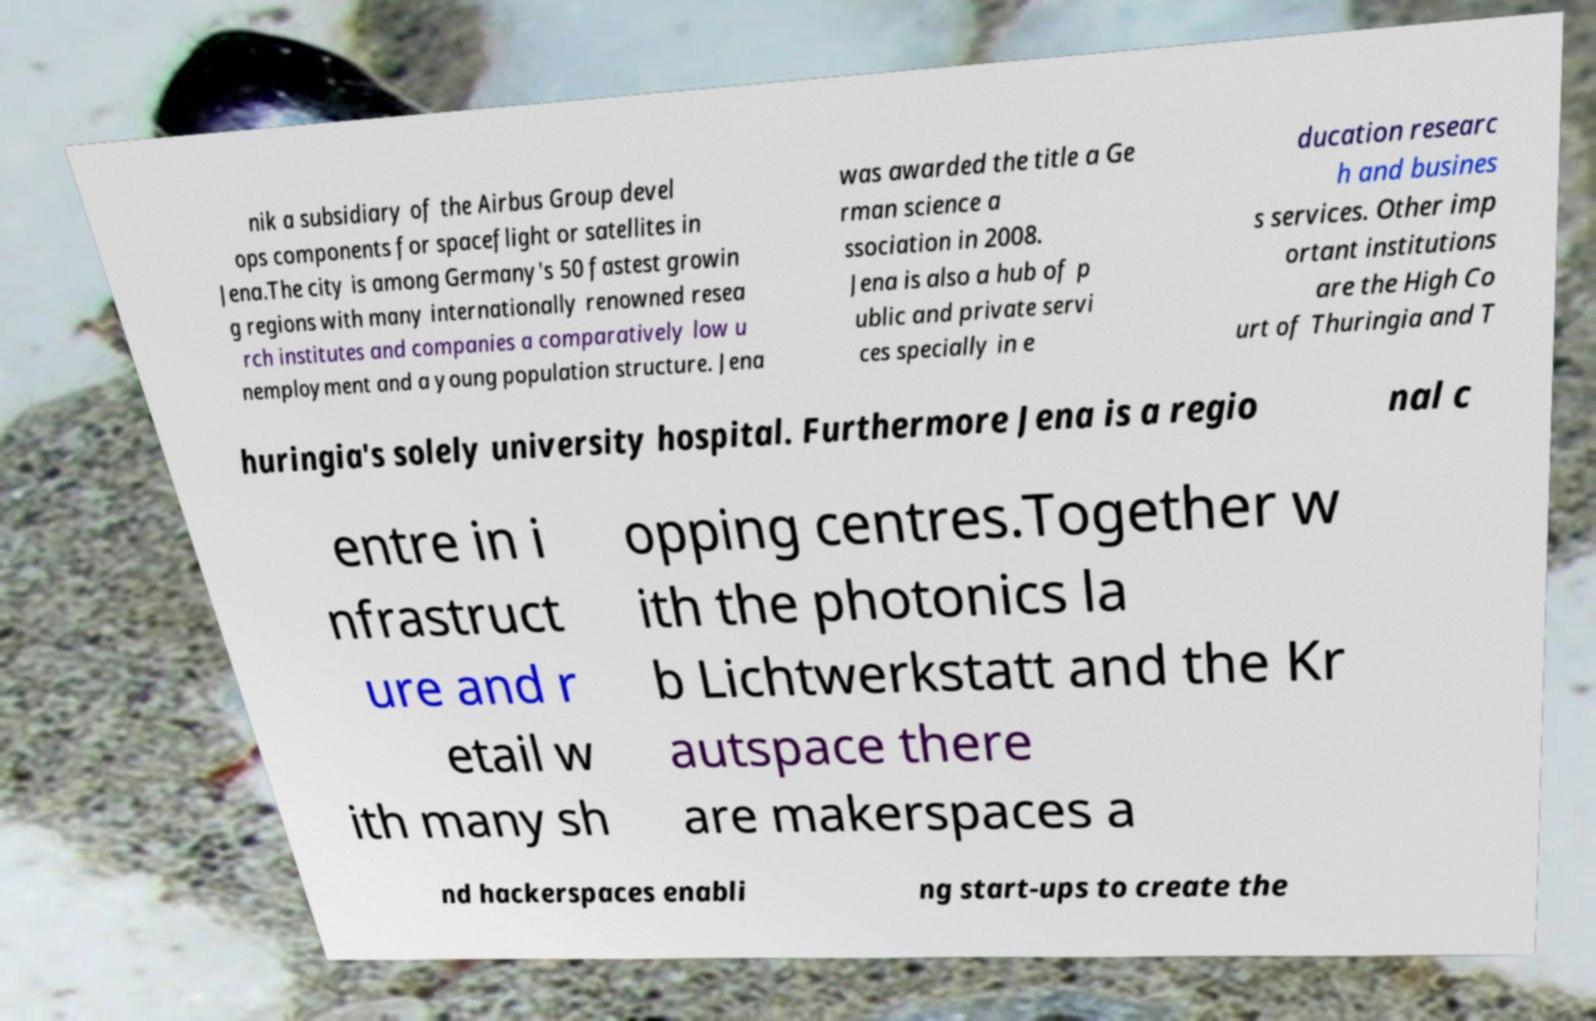Could you assist in decoding the text presented in this image and type it out clearly? nik a subsidiary of the Airbus Group devel ops components for spaceflight or satellites in Jena.The city is among Germany's 50 fastest growin g regions with many internationally renowned resea rch institutes and companies a comparatively low u nemployment and a young population structure. Jena was awarded the title a Ge rman science a ssociation in 2008. Jena is also a hub of p ublic and private servi ces specially in e ducation researc h and busines s services. Other imp ortant institutions are the High Co urt of Thuringia and T huringia's solely university hospital. Furthermore Jena is a regio nal c entre in i nfrastruct ure and r etail w ith many sh opping centres.Together w ith the photonics la b Lichtwerkstatt and the Kr autspace there are makerspaces a nd hackerspaces enabli ng start-ups to create the 